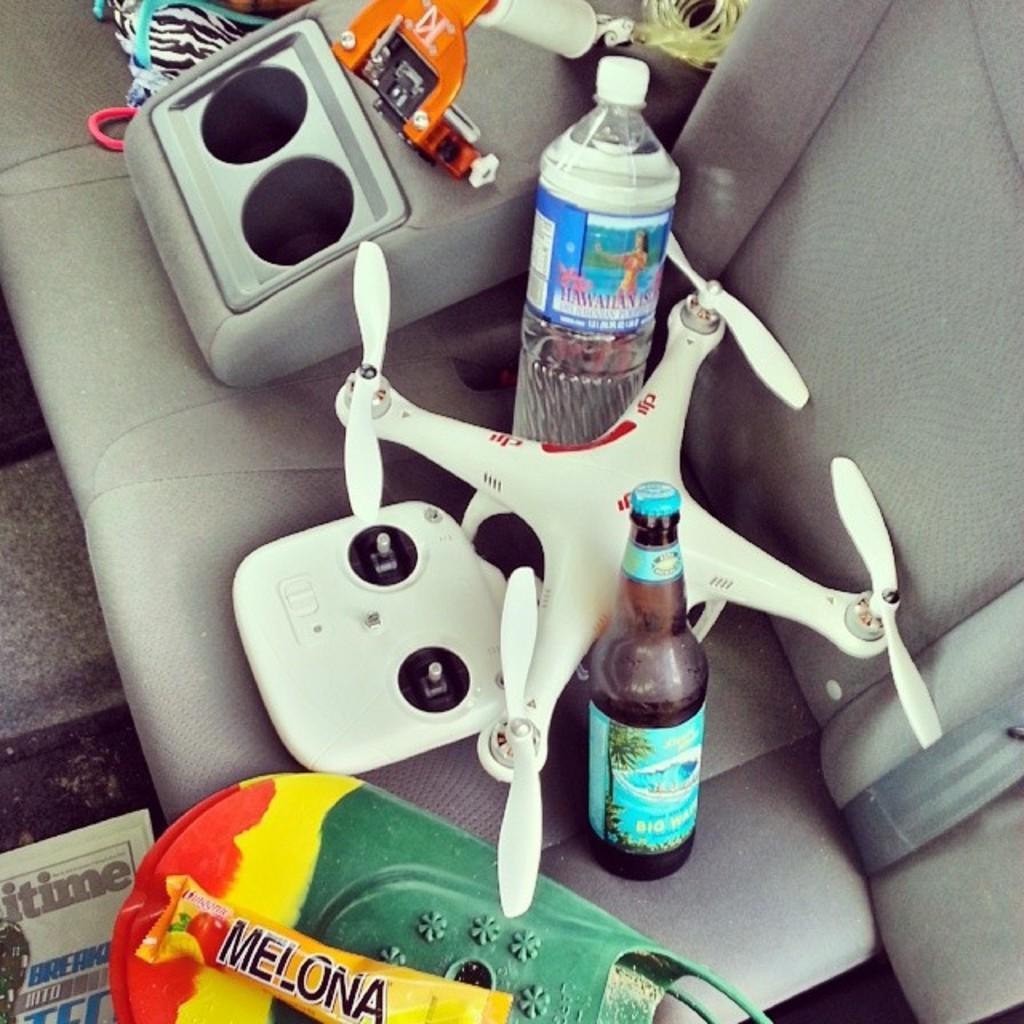What is present in the image that people can sit on? There is a seat in the image. What can be found on the seat? There are objects placed on the seat. What type of lumber is being used to construct the seat in the image? There is no information about the construction material of the seat in the image, so it cannot be determined. 